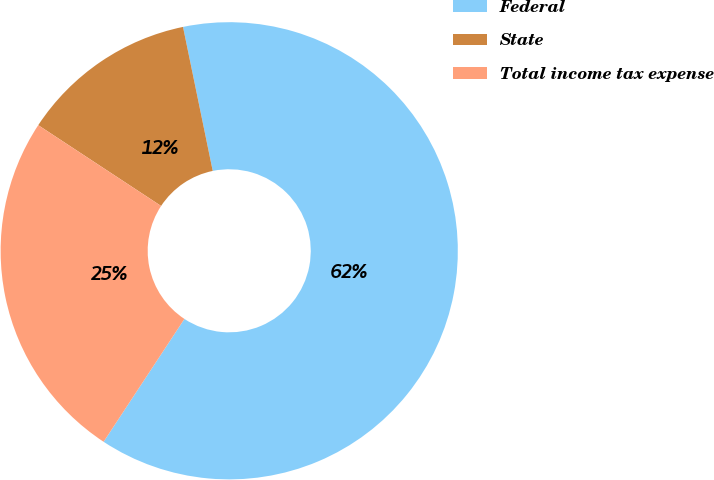<chart> <loc_0><loc_0><loc_500><loc_500><pie_chart><fcel>Federal<fcel>State<fcel>Total income tax expense<nl><fcel>62.5%<fcel>12.5%<fcel>25.0%<nl></chart> 